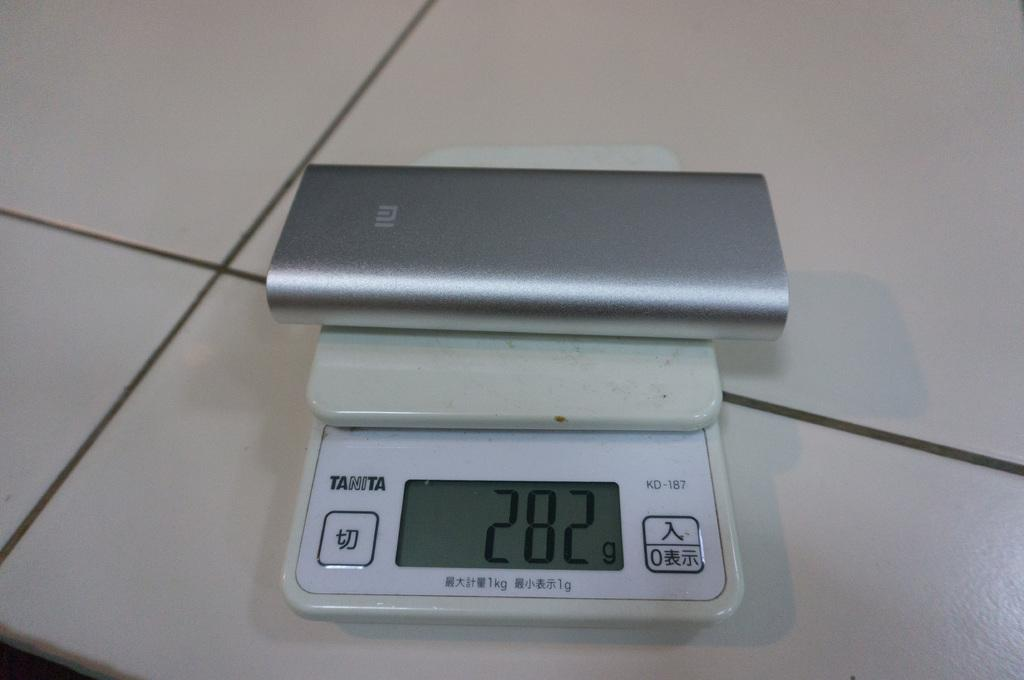What is the main object in the center of the picture? There is a weighing machine and an electronic gadget in the center of the picture. What can you tell me about the floor in the image? The floor has white tiles. How many giants are visible in the image? There are no giants present in the image. What type of exchange is taking place between the objects in the image? There is no exchange taking place between the objects in the image. 